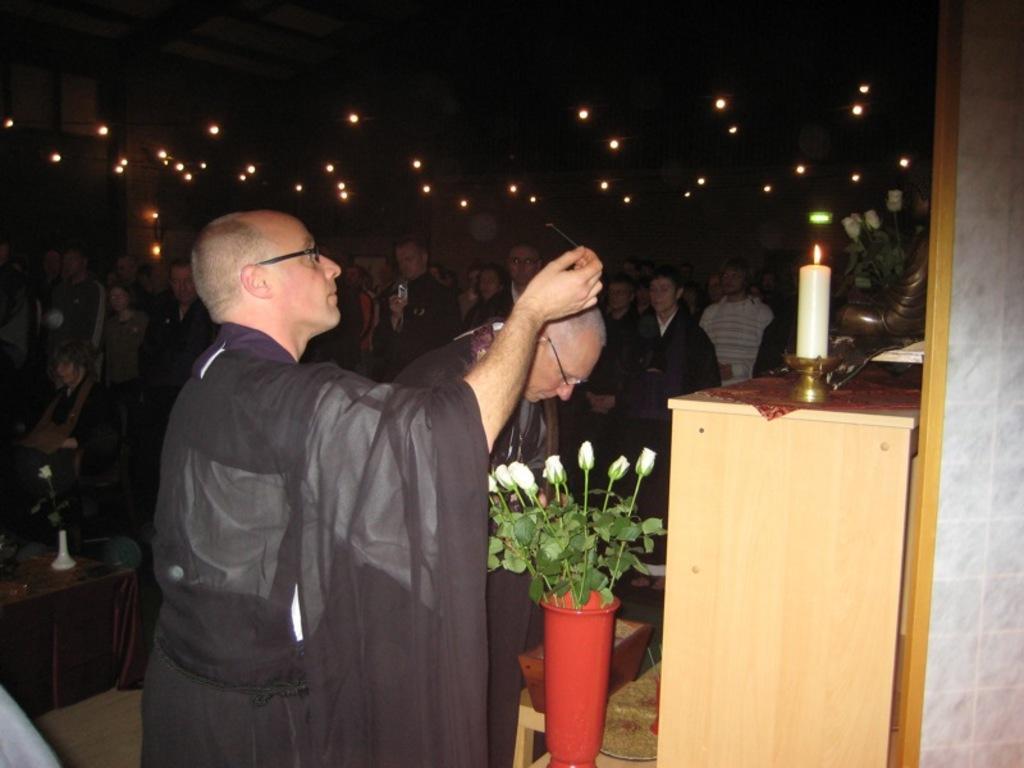Please provide a concise description of this image. In the image we can see there are lot of people who are standing and there is a man who is lighting a candle in front which is on the table and for the man there are rose flowers in the vase. 